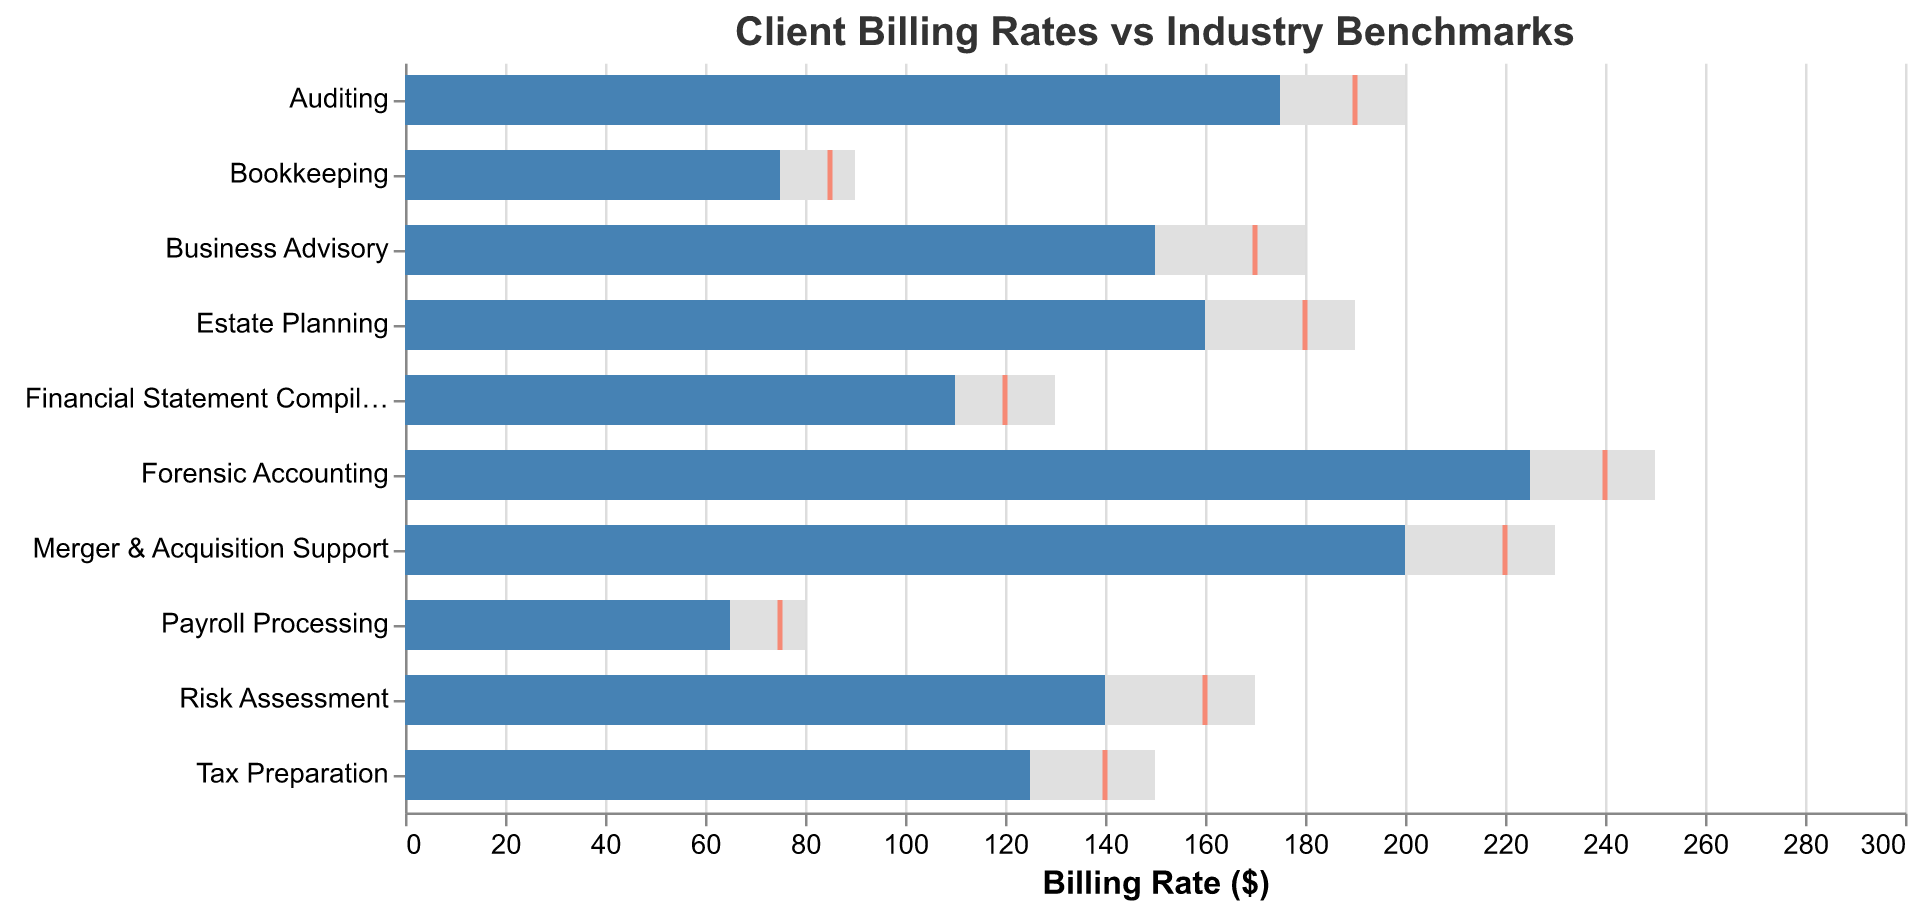What's the title of the figure? The title of the figure is prominently displayed at the top. Look for the text that summarizes what the chart is about.
Answer: Client Billing Rates vs Industry Benchmarks What is the actual billing rate for Tax Preparation? Locate the "Tax Preparation" service along the y-axis, and then observe the length of the blue bar associated with it.
Answer: 125 Which service has the highest actual billing rate? Compare the lengths of the blue bars for all services. The longest blue bar represents the highest billing rate.
Answer: Forensic Accounting For Bookkeeping, how much lower is the actual rate compared to the benchmark? Find the lengths of the blue bar (actual rate) and the grey bar (benchmark) for Bookkeeping and subtract the actual rate from the benchmark.
Answer: 15 Which services have an actual rate less than their target rate? Compare the position of blue bars (actual rate) relative to the red tick marks (target rate) for each service. Identify those where blue bars are shorter.
Answer: Tax Preparation, Auditing, Bookkeeping, Financial Statement Compilation, Payroll Processing, Business Advisory, Estate Planning, Risk Assessment, Merger & Acquisition Support What is the difference between the benchmark and the target for Auditing? For Auditing, find the lengths of the grey bar (benchmark) and the position of the red tick mark (target), then subtract the target from the benchmark.
Answer: 10 Which service has the smallest gap between the actual rate and the target rate? Measure the distance between the end of the blue bar (actual rate) and the position of the red tick mark (target) for each service, and find the smallest gap.
Answer: Forensic Accounting Which service is the closest to meeting its benchmark rate? Identify the service where the blue bar (actual rate) is closest to the end of the grey bar (benchmark), indicating the smallest difference.
Answer: Forensic Accounting For Payroll Processing, what percent of the benchmark is the actual rate? Divide the actual rate by the benchmark rate and multiply by 100 for Payroll Processing. The benchmark rate is 80 and the actual rate is 65. Calculation: (65/80) * 100
Answer: 81.25% Of the services listed, which one most exceeds its target rate? Identify the service where the blue bar (actual rate) extends the furthest beyond the position of the red tick mark (target).
Answer: Forensic Accounting Which services have an actual rate that is greater than both their benchmark and target? Compare the blue bar (actual rate) with the grey bar (benchmark) and the red tick mark (target) for each service. Identify those where the blue bar is longer than both.
Answer: Forensic Accounting 